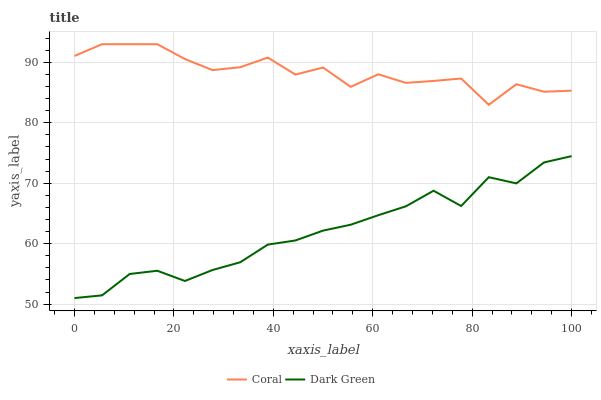Does Dark Green have the minimum area under the curve?
Answer yes or no. Yes. Does Coral have the maximum area under the curve?
Answer yes or no. Yes. Does Dark Green have the maximum area under the curve?
Answer yes or no. No. Is Dark Green the smoothest?
Answer yes or no. Yes. Is Coral the roughest?
Answer yes or no. Yes. Is Dark Green the roughest?
Answer yes or no. No. Does Dark Green have the lowest value?
Answer yes or no. Yes. Does Coral have the highest value?
Answer yes or no. Yes. Does Dark Green have the highest value?
Answer yes or no. No. Is Dark Green less than Coral?
Answer yes or no. Yes. Is Coral greater than Dark Green?
Answer yes or no. Yes. Does Dark Green intersect Coral?
Answer yes or no. No. 